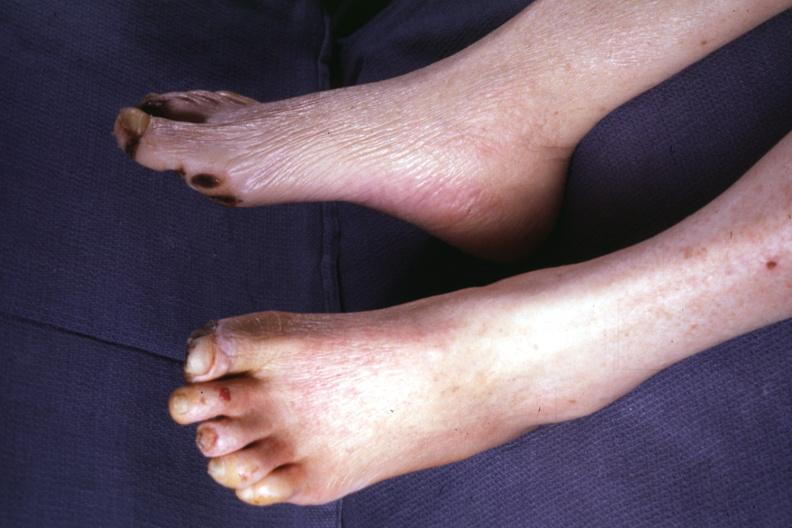does this image show typical gangrene?
Answer the question using a single word or phrase. Yes 